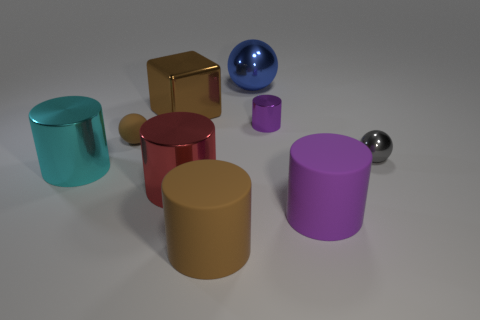There is a big thing to the left of the metallic block; is it the same color as the tiny matte ball?
Your answer should be very brief. No. What number of things are either large matte objects that are right of the blue thing or blue cubes?
Your answer should be very brief. 1. What is the material of the small ball to the left of the large brown thing behind the brown object to the right of the block?
Ensure brevity in your answer.  Rubber. Is the number of brown cylinders that are behind the cyan thing greater than the number of large metallic cylinders that are behind the small matte sphere?
Ensure brevity in your answer.  No. What number of blocks are brown things or big brown rubber things?
Ensure brevity in your answer.  1. How many gray things are in front of the large shiny thing that is to the left of the large metal block that is on the left side of the big red metal cylinder?
Your answer should be compact. 0. What material is the ball that is the same color as the shiny cube?
Offer a terse response. Rubber. Are there more brown matte objects than large blocks?
Make the answer very short. Yes. Do the gray thing and the blue object have the same size?
Your answer should be very brief. No. What number of things are either big red cylinders or big matte cylinders?
Give a very brief answer. 3. 